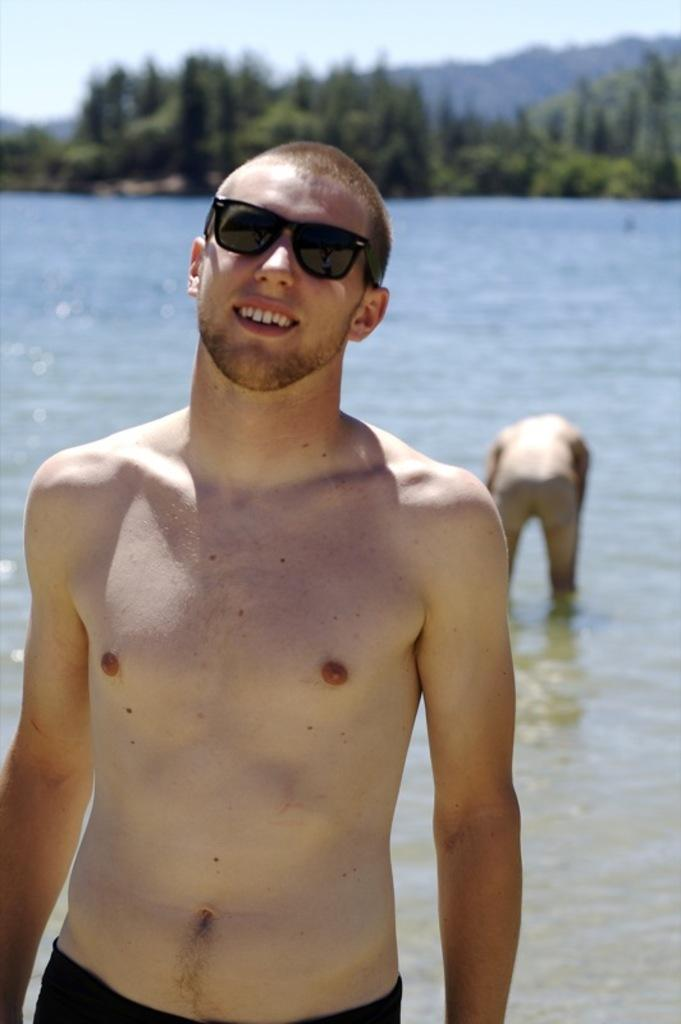What is the person wearing in the image? The person is wearing goggles in the image. What is the other person doing in the image? The other person is in the water. What can be seen in the background of the image? There are trees in the background of the image. How would you describe the background of the image? The background of the image is blurry. What type of nerve can be seen in the image? There is no nerve present in the image. What kind of soup is being served in the image? There is no soup present in the image. 